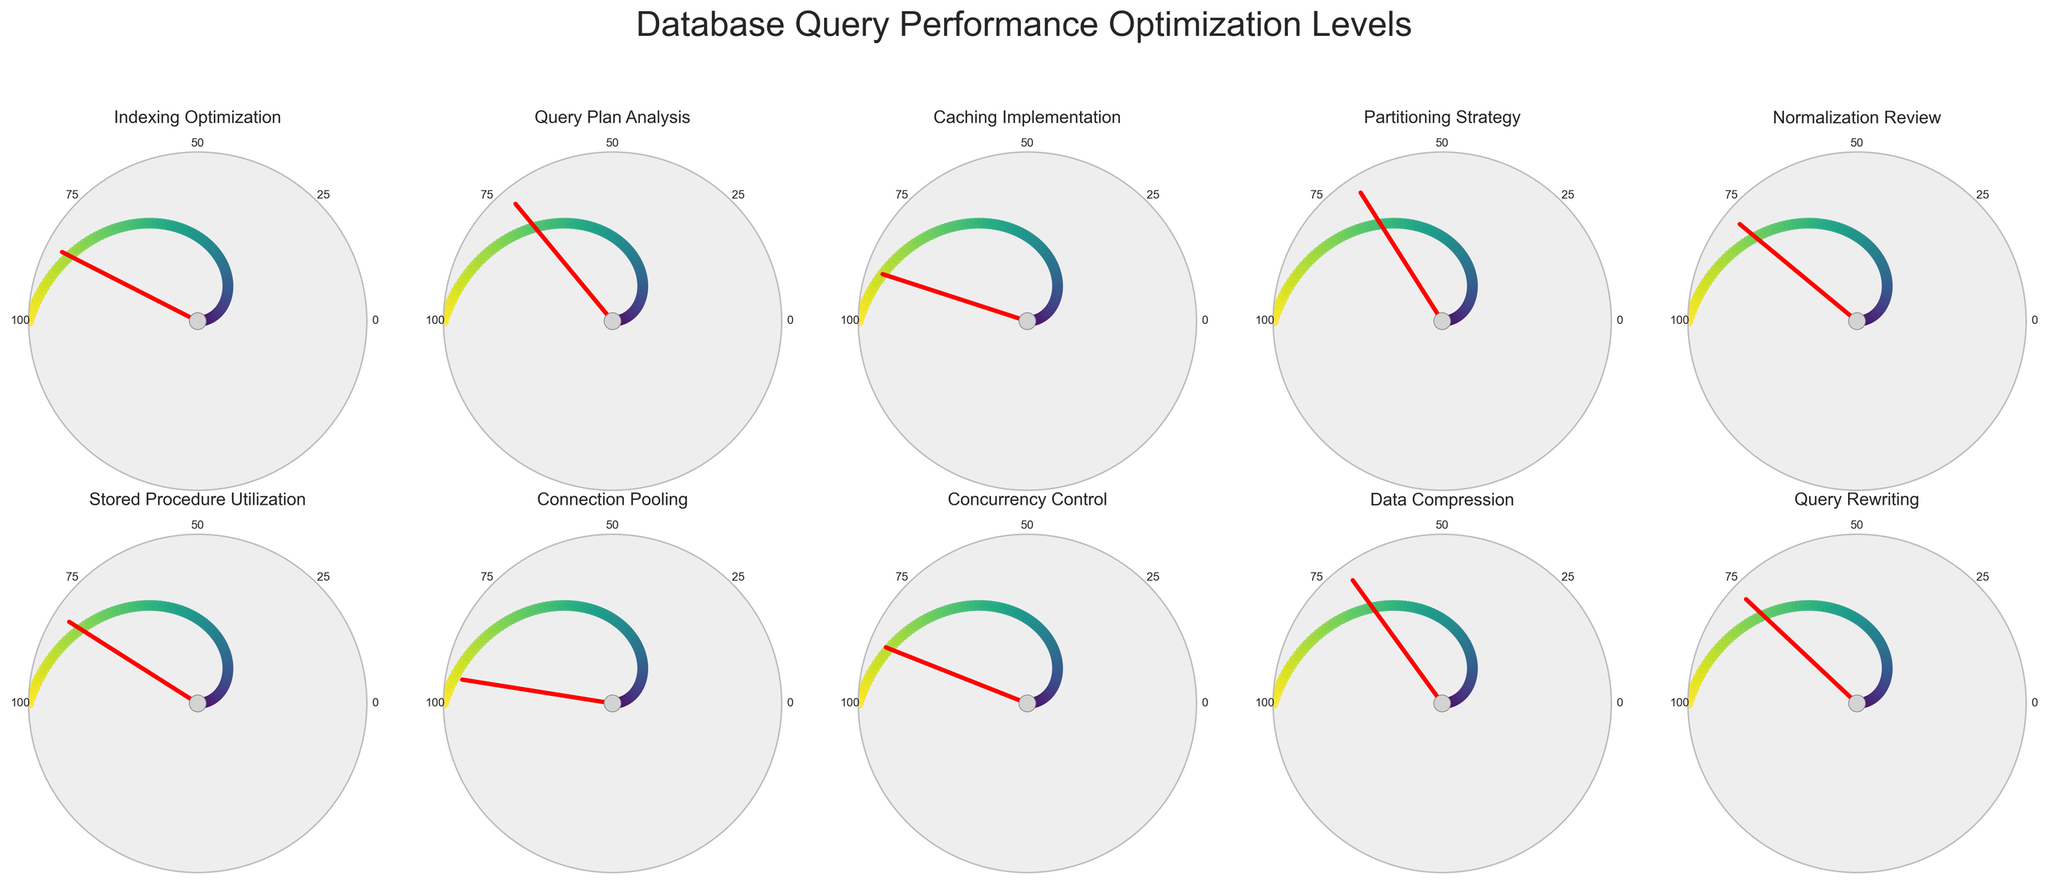What's the highest optimization level represented in the figure? The highest value on the gauge charts represents the highest optimization level. By looking at each gauge chart, we can see that the highest value is 95 for "Connection Pooling".
Answer: Connection Pooling at 95% What's the lowest optimization level shown? The lowest value on the gauge charts represents the lowest optimization level. Among all the charts, the lowest value is 68 for "Partitioning Strategy".
Answer: Partitioning Strategy at 68% What's the average optimization level across all the categories? To find the average, sum all the optimization levels: (85 + 72 + 90 + 68 + 78 + 82 + 95 + 88 + 70 + 76) = 804. Then divide this sum by the number of categories (10). 804 / 10 = 80.4
Answer: 80.4% Which optimization technique is closest to the average optimization level? First, find the average optimization level, which is 80.4%. Then identify the value closest to 80.4% by inspecting each gauge chart: the values are 85, 72, 90, 68, 78, 82, 95, 88, 70, 76. "Normalization Review" at 78% is closest to 80.4%.
Answer: Normalization Review at 78% How many optimization techniques have a level above 80%? Count the values in the gauge charts that are above 80%: Indexing Optimization (85), Caching Implementation (90), Stored Procedure Utilization (82), Connection Pooling (95), Concurrency Control (88). There are 5 techniques.
Answer: 5 Which appears more frequently: optimization levels above 85% or below 70%? Count the number of techniques with levels above 85% and below 70%. Above 85%: three (Connection Pooling 95%, Caching Implementation 90%, Concurrency Control 88%). Below 70%: two (Partitioning Strategy 68%, Data Compression 70%). There are more above 85%.
Answer: Above 85% Which optimization technique represents exactly 76%? Scan each gauge chart for the value 76. The gauge chart for "Query Rewriting" shows a value of 76%.
Answer: Query Rewriting at 76% What is the range of optimization levels displayed in the figure? Identify the highest and lowest values among the optimization levels: Highest = 95 (Connection Pooling), Lowest = 68 (Partitioning Strategy). The range is 95 - 68 = 27.
Answer: 27 Which two techniques have levels closest to each other? Compare the levels and find the smallest difference. The closest levels are for "Stored Procedure Utilization" (82) and "Normalization Review" (78), with a difference of 4.
Answer: Stored Procedure Utilization and Normalization Review How many techniques have optimization levels within the range of 70% to 80%? Count the techniques with levels between 70% and 80% inclusive. These are: Query Plan Analysis (72%), Normalization Review (78%), Data Compression (70%), Query Rewriting (76%). There are 4 techniques.
Answer: 4 